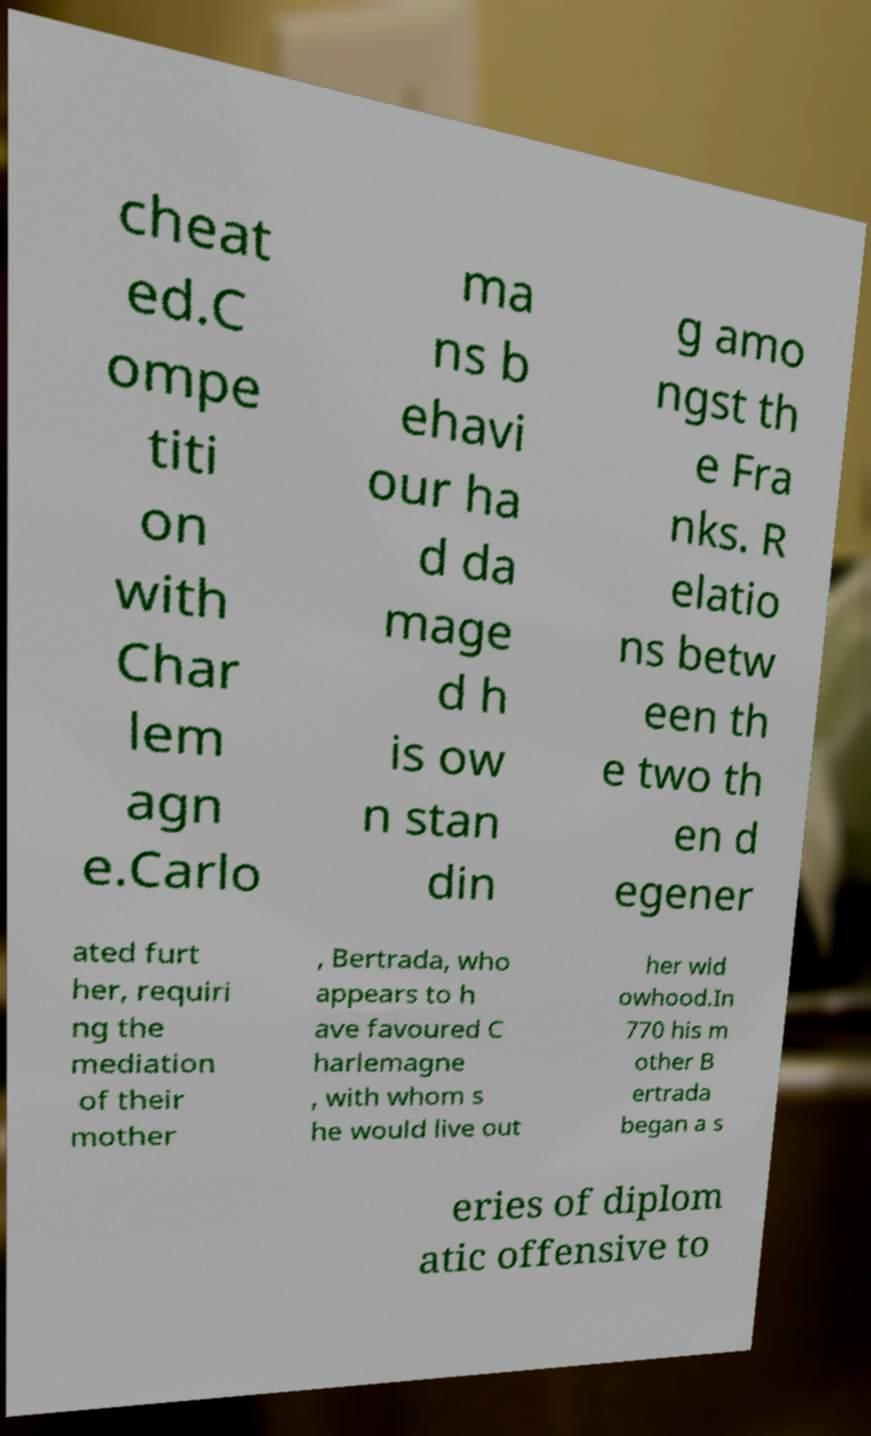Can you accurately transcribe the text from the provided image for me? cheat ed.C ompe titi on with Char lem agn e.Carlo ma ns b ehavi our ha d da mage d h is ow n stan din g amo ngst th e Fra nks. R elatio ns betw een th e two th en d egener ated furt her, requiri ng the mediation of their mother , Bertrada, who appears to h ave favoured C harlemagne , with whom s he would live out her wid owhood.In 770 his m other B ertrada began a s eries of diplom atic offensive to 